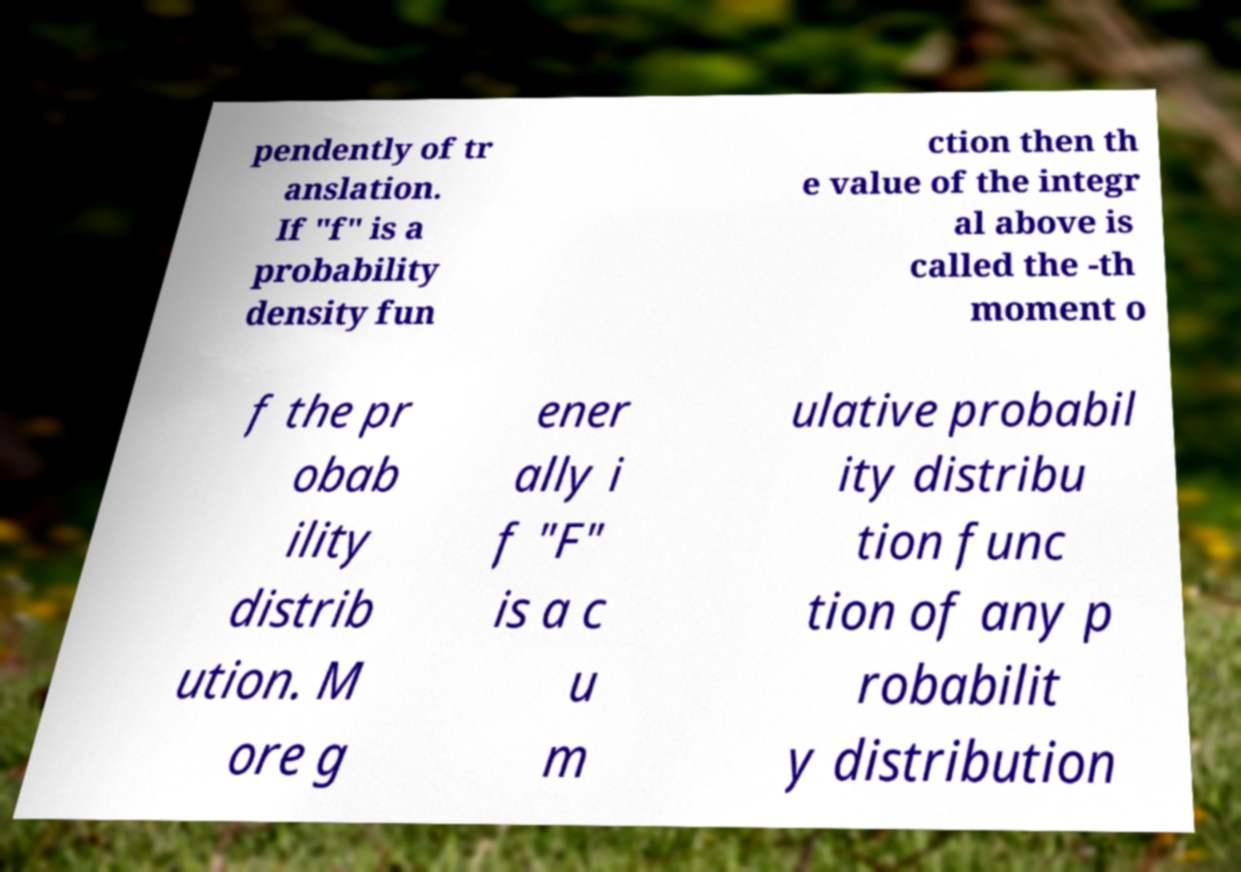There's text embedded in this image that I need extracted. Can you transcribe it verbatim? pendently of tr anslation. If "f" is a probability density fun ction then th e value of the integr al above is called the -th moment o f the pr obab ility distrib ution. M ore g ener ally i f "F" is a c u m ulative probabil ity distribu tion func tion of any p robabilit y distribution 